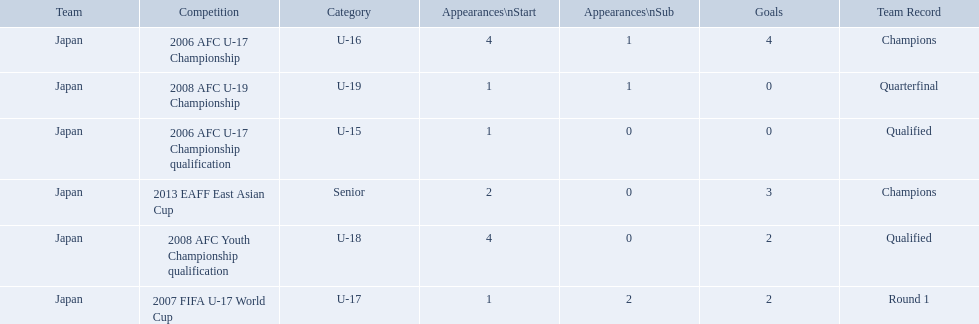What competitions did japan compete in with yoichiro kakitani? 2006 AFC U-17 Championship qualification, 2006 AFC U-17 Championship, 2007 FIFA U-17 World Cup, 2008 AFC Youth Championship qualification, 2008 AFC U-19 Championship, 2013 EAFF East Asian Cup. Of those competitions, which were held in 2007 and 2013? 2007 FIFA U-17 World Cup, 2013 EAFF East Asian Cup. Of the 2007 fifa u-17 world cup and the 2013 eaff east asian cup, which did japan have the most starting appearances? 2013 EAFF East Asian Cup. 